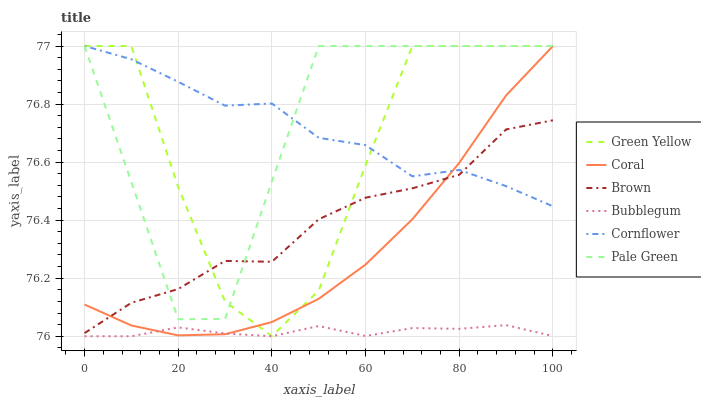Does Bubblegum have the minimum area under the curve?
Answer yes or no. Yes. Does Pale Green have the maximum area under the curve?
Answer yes or no. Yes. Does Cornflower have the minimum area under the curve?
Answer yes or no. No. Does Cornflower have the maximum area under the curve?
Answer yes or no. No. Is Bubblegum the smoothest?
Answer yes or no. Yes. Is Green Yellow the roughest?
Answer yes or no. Yes. Is Cornflower the smoothest?
Answer yes or no. No. Is Cornflower the roughest?
Answer yes or no. No. Does Coral have the lowest value?
Answer yes or no. No. Does Green Yellow have the highest value?
Answer yes or no. Yes. Does Bubblegum have the highest value?
Answer yes or no. No. Is Bubblegum less than Brown?
Answer yes or no. Yes. Is Green Yellow greater than Bubblegum?
Answer yes or no. Yes. Does Cornflower intersect Coral?
Answer yes or no. Yes. Is Cornflower less than Coral?
Answer yes or no. No. Is Cornflower greater than Coral?
Answer yes or no. No. Does Bubblegum intersect Brown?
Answer yes or no. No. 